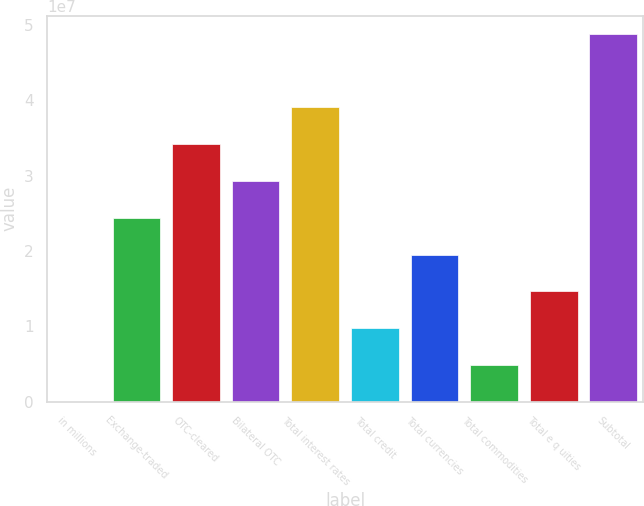<chart> <loc_0><loc_0><loc_500><loc_500><bar_chart><fcel>in millions<fcel>Exchange-traded<fcel>OTC-cleared<fcel>Bilateral OTC<fcel>Total interest rates<fcel>Total credit<fcel>Total currencies<fcel>Total commodities<fcel>Total e q uities<fcel>Subtotal<nl><fcel>2017<fcel>2.44337e+07<fcel>3.42063e+07<fcel>2.932e+07<fcel>3.90927e+07<fcel>9.77468e+06<fcel>1.95473e+07<fcel>4.88835e+06<fcel>1.4661e+07<fcel>4.87868e+07<nl></chart> 